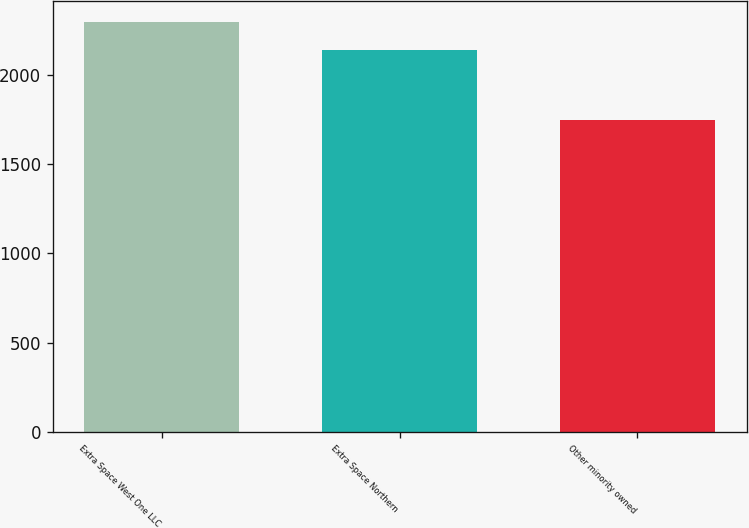<chart> <loc_0><loc_0><loc_500><loc_500><bar_chart><fcel>Extra Space West One LLC<fcel>Extra Space Northern<fcel>Other minority owned<nl><fcel>2299<fcel>2138<fcel>1745<nl></chart> 